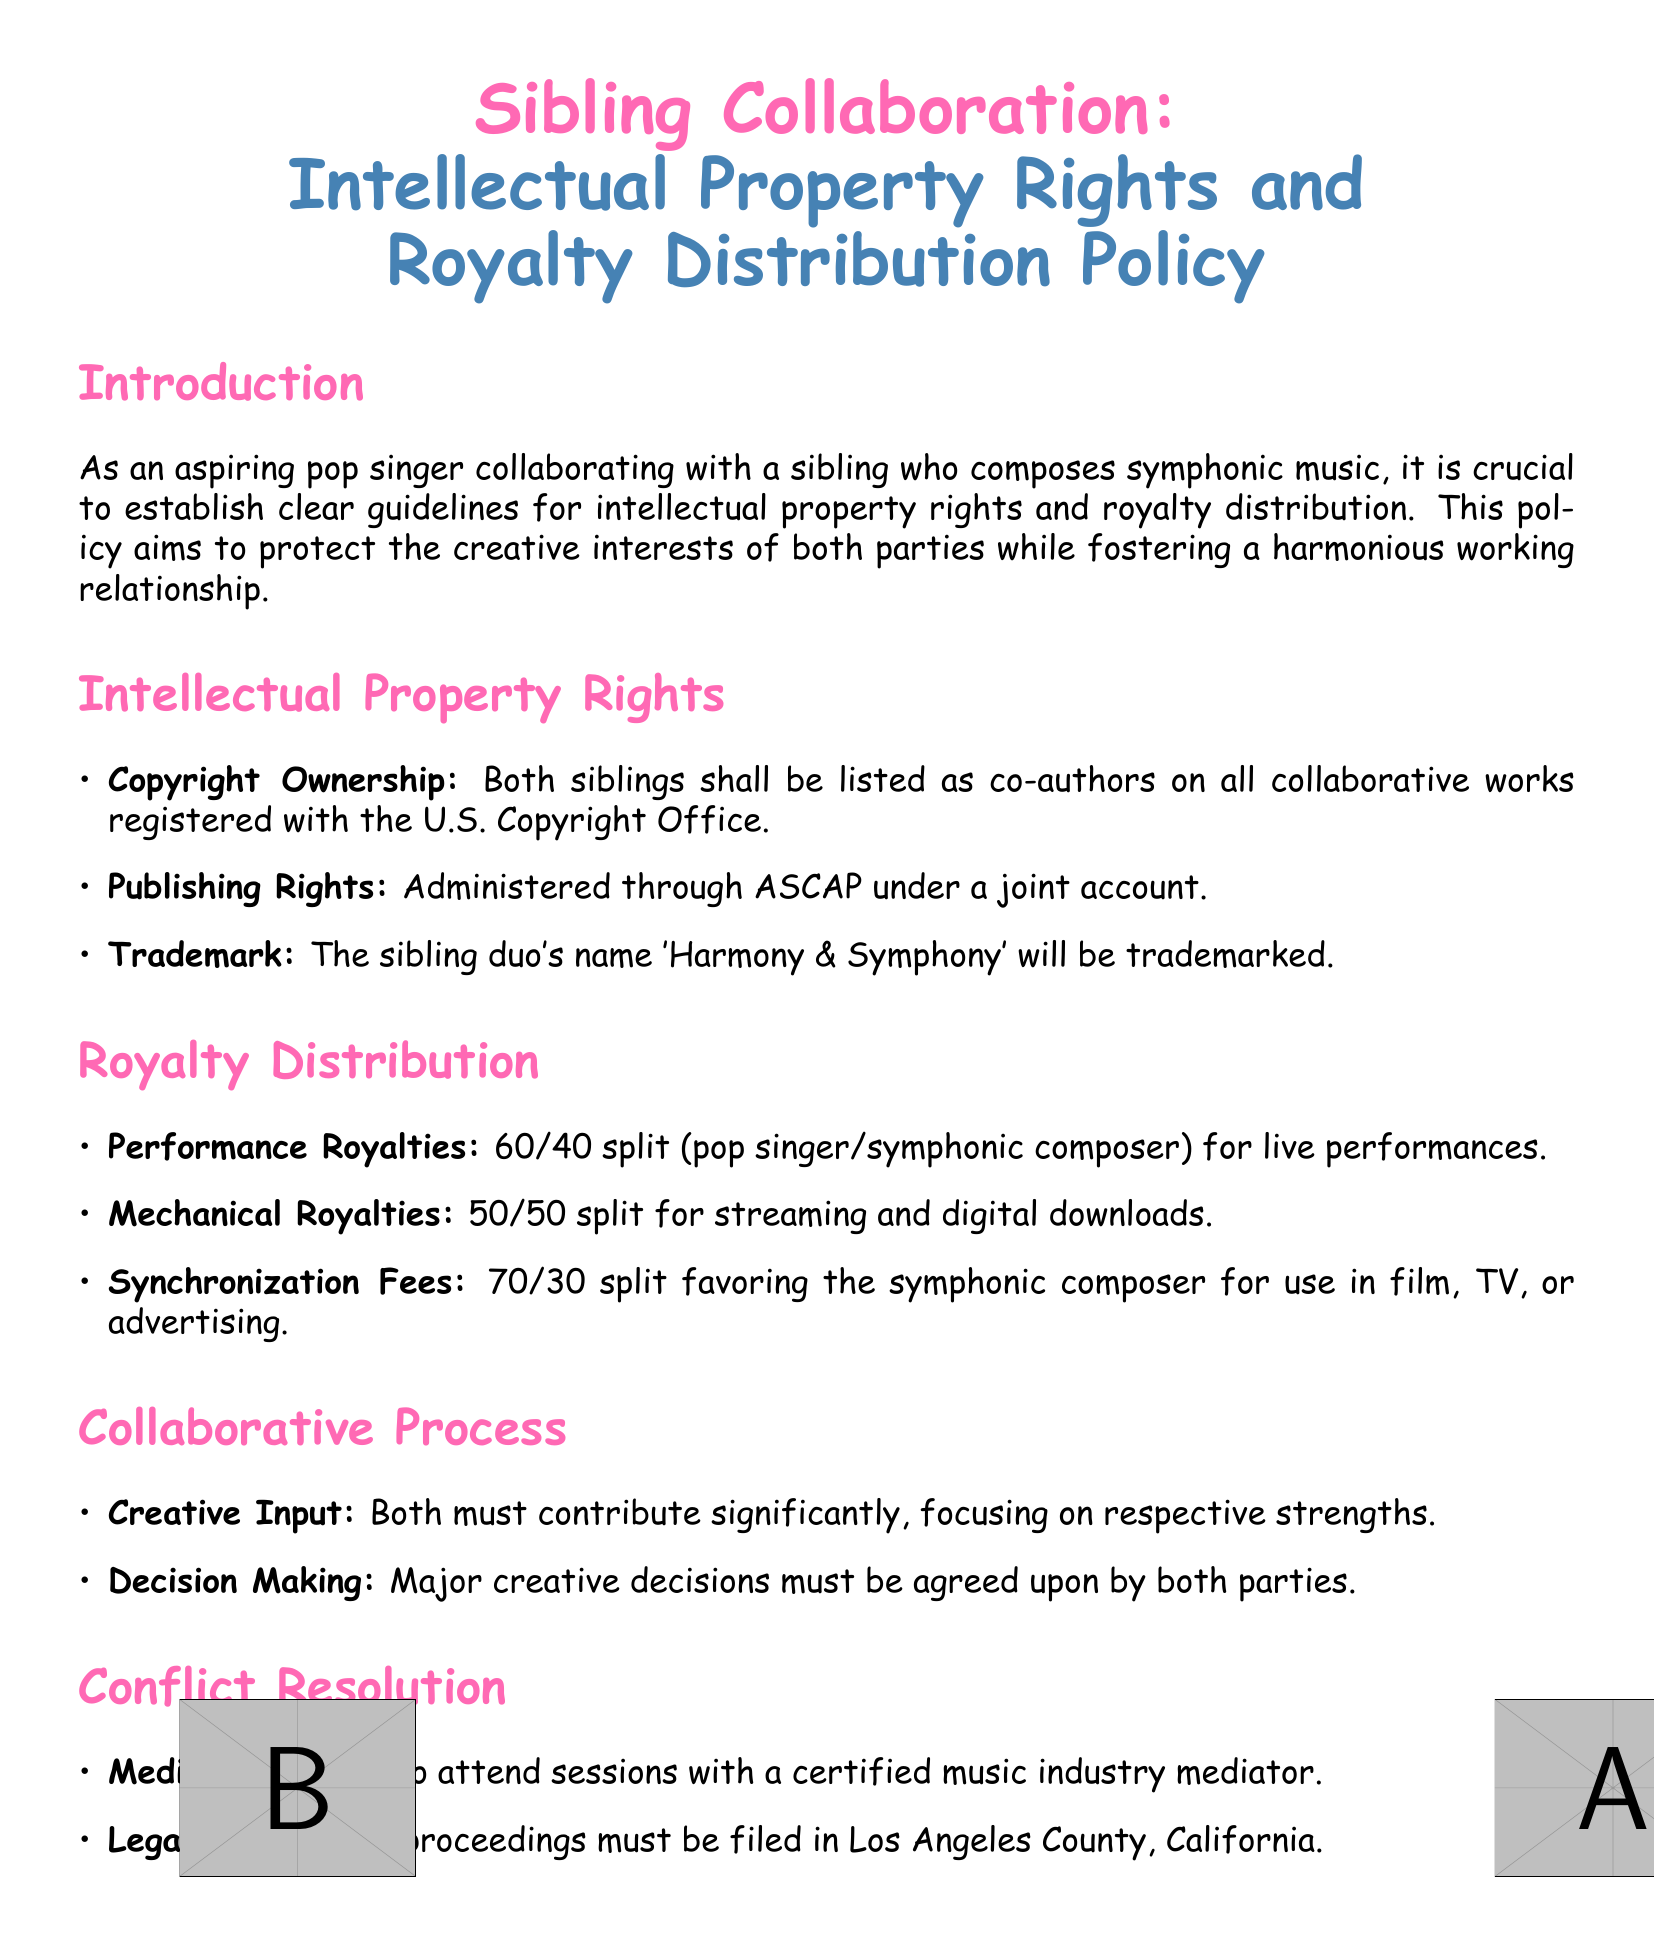What is the copyright ownership arrangement? The copyright ownership arrangement states that both siblings shall be listed as co-authors on all collaborative works registered with the U.S. Copyright Office.
Answer: co-authors What is the performance royalties split? The performance royalties split is detailed in the document as 60/40 in favor of the pop singer for live performances.
Answer: 60/40 What is the trademarked name of the sibling duo? The trademarked name of the sibling duo is stated in the document as 'Harmony & Symphony'.
Answer: Harmony & Symphony How are mechanical royalties split? Mechanical royalties are split equally between the siblings, which is indicated as 50/50 in the document.
Answer: 50/50 Where must legal proceedings be filed? The document specifies that any legal proceedings must be filed in Los Angeles County, California.
Answer: Los Angeles County What is required for major creative decisions? Major creative decisions must be agreed upon by both parties, as mentioned in the document.
Answer: both parties What is the mediation requirement? The mediation requirement states that they must agree to attend sessions with a certified music industry mediator.
Answer: certified music industry mediator What are the synchronization fees split? The synchronization fees split is described in the document as 70/30 favoring the symphonic composer.
Answer: 70/30 